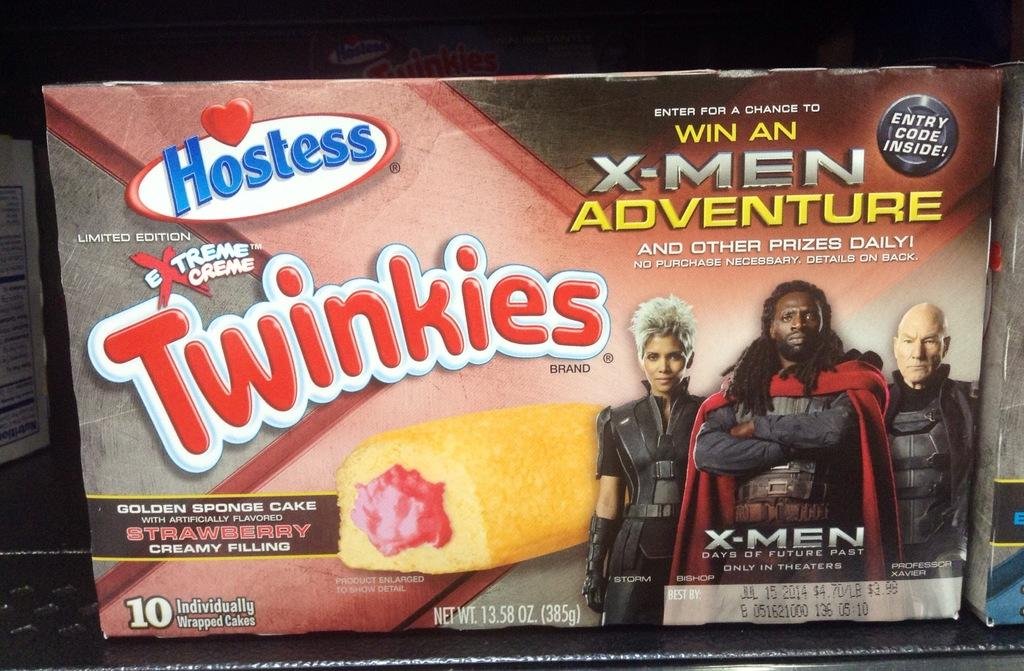What objects are visible in the image? There are boxes in the image. How are the boxes arranged? The boxes are in a rack. What is depicted on one of the boxes? There is a print of three people with dresses on one of the boxes, and it includes food. Is there any text on the box? Yes, there is text written on the box. What type of jelly can be seen in the image? There is no jelly present in the image. How does the volleyball game progress in the image? There is no volleyball game depicted in the image. 